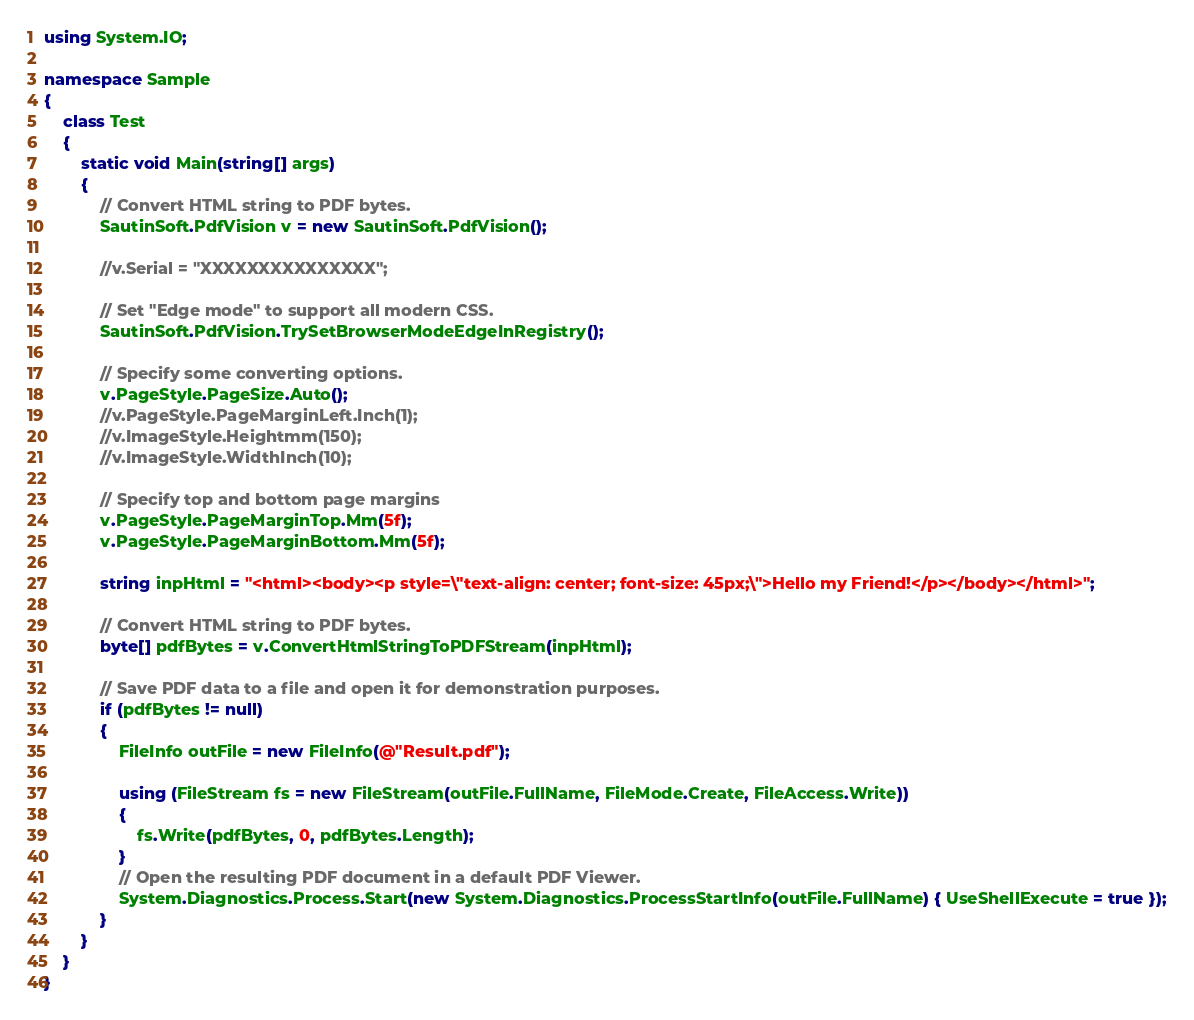Convert code to text. <code><loc_0><loc_0><loc_500><loc_500><_C#_>using System.IO;

namespace Sample
{
    class Test
    {
        static void Main(string[] args)
        {
            // Convert HTML string to PDF bytes.
            SautinSoft.PdfVision v = new SautinSoft.PdfVision();

            //v.Serial = "XXXXXXXXXXXXXXX";

            // Set "Edge mode" to support all modern CSS.
            SautinSoft.PdfVision.TrySetBrowserModeEdgeInRegistry();

            // Specify some converting options.
            v.PageStyle.PageSize.Auto();
            //v.PageStyle.PageMarginLeft.Inch(1);
            //v.ImageStyle.Heightmm(150);
            //v.ImageStyle.WidthInch(10);

            // Specify top and bottom page margins
            v.PageStyle.PageMarginTop.Mm(5f);
            v.PageStyle.PageMarginBottom.Mm(5f);

            string inpHtml = "<html><body><p style=\"text-align: center; font-size: 45px;\">Hello my Friend!</p></body></html>";

            // Convert HTML string to PDF bytes.
            byte[] pdfBytes = v.ConvertHtmlStringToPDFStream(inpHtml);

            // Save PDF data to a file and open it for demonstration purposes.
            if (pdfBytes != null)
            {
                FileInfo outFile = new FileInfo(@"Result.pdf");

                using (FileStream fs = new FileStream(outFile.FullName, FileMode.Create, FileAccess.Write))
                {
                    fs.Write(pdfBytes, 0, pdfBytes.Length);
                }
				// Open the resulting PDF document in a default PDF Viewer.
                System.Diagnostics.Process.Start(new System.Diagnostics.ProcessStartInfo(outFile.FullName) { UseShellExecute = true });
            }
        }
    }
}
</code> 